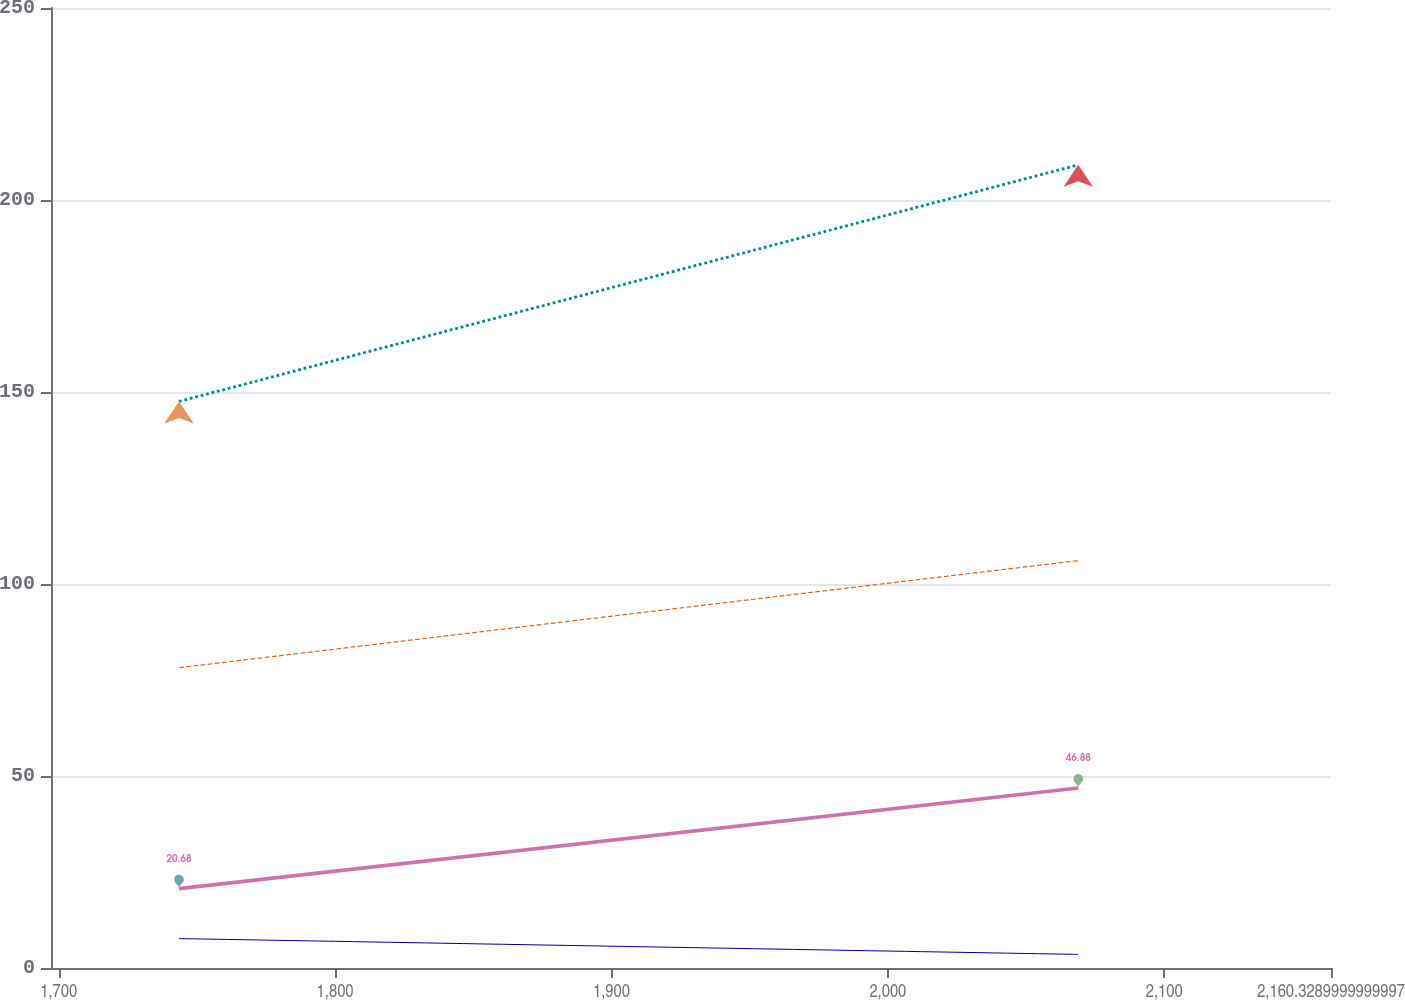Convert chart. <chart><loc_0><loc_0><loc_500><loc_500><line_chart><ecel><fcel>Genco<fcel>CIPS<fcel>IP<fcel>CILCO<nl><fcel>1743.53<fcel>147.54<fcel>78.2<fcel>7.66<fcel>20.68<nl><fcel>2068.88<fcel>209.15<fcel>106.1<fcel>3.54<fcel>46.88<nl><fcel>2206.64<fcel>153.7<fcel>66.16<fcel>2.83<fcel>29.77<nl></chart> 